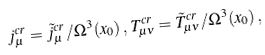<formula> <loc_0><loc_0><loc_500><loc_500>j _ { \mu } ^ { c r } = \tilde { j } _ { \mu } ^ { c r } / \Omega ^ { 3 } ( x _ { 0 } ) \, , \, T _ { \mu \nu } ^ { c r } = \tilde { T } _ { \mu \nu } ^ { c r } / \Omega ^ { 3 } ( x _ { 0 } ) \, ,</formula> 